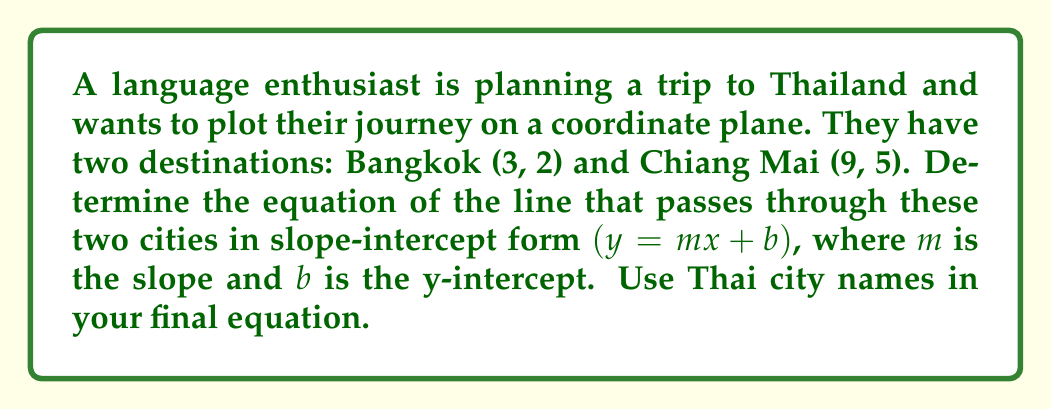Can you answer this question? To find the equation of the line passing through Bangkok (3, 2) and Chiang Mai (9, 5), we'll follow these steps:

1. Calculate the slope $(m)$ using the slope formula:
   $$m = \frac{y_2 - y_1}{x_2 - x_1} = \frac{5 - 2}{9 - 3} = \frac{3}{6} = \frac{1}{2}$$

2. Use the point-slope form of a line with either point. Let's use Bangkok (3, 2):
   $$y - y_1 = m(x - x_1)$$
   $$y - 2 = \frac{1}{2}(x - 3)$$

3. Expand the equation:
   $$y - 2 = \frac{1}{2}x - \frac{3}{2}$$

4. Solve for $y$ to get the slope-intercept form:
   $$y = \frac{1}{2}x - \frac{3}{2} + 2$$
   $$y = \frac{1}{2}x + \frac{1}{2}$$

5. Replace $x$ and $y$ with Thai city names:
   $$(Chiang Mai_y) = \frac{1}{2}(Bangkok_x) + \frac{1}{2}$$
Answer: $(Chiang Mai_y) = \frac{1}{2}(Bangkok_x) + \frac{1}{2}$ 